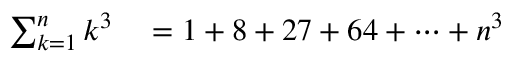<formula> <loc_0><loc_0><loc_500><loc_500>\begin{array} { r l } { \sum _ { k = 1 } ^ { n } k ^ { 3 } } & = 1 + 8 + 2 7 + 6 4 + \cdots + n ^ { 3 } } \end{array}</formula> 